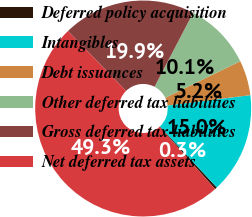Convert chart to OTSL. <chart><loc_0><loc_0><loc_500><loc_500><pie_chart><fcel>Deferred policy acquisition<fcel>Intangibles<fcel>Debt issuances<fcel>Other deferred tax liabilities<fcel>Gross deferred tax liabilities<fcel>Net deferred tax assets<nl><fcel>0.34%<fcel>15.03%<fcel>5.24%<fcel>10.13%<fcel>19.93%<fcel>49.33%<nl></chart> 